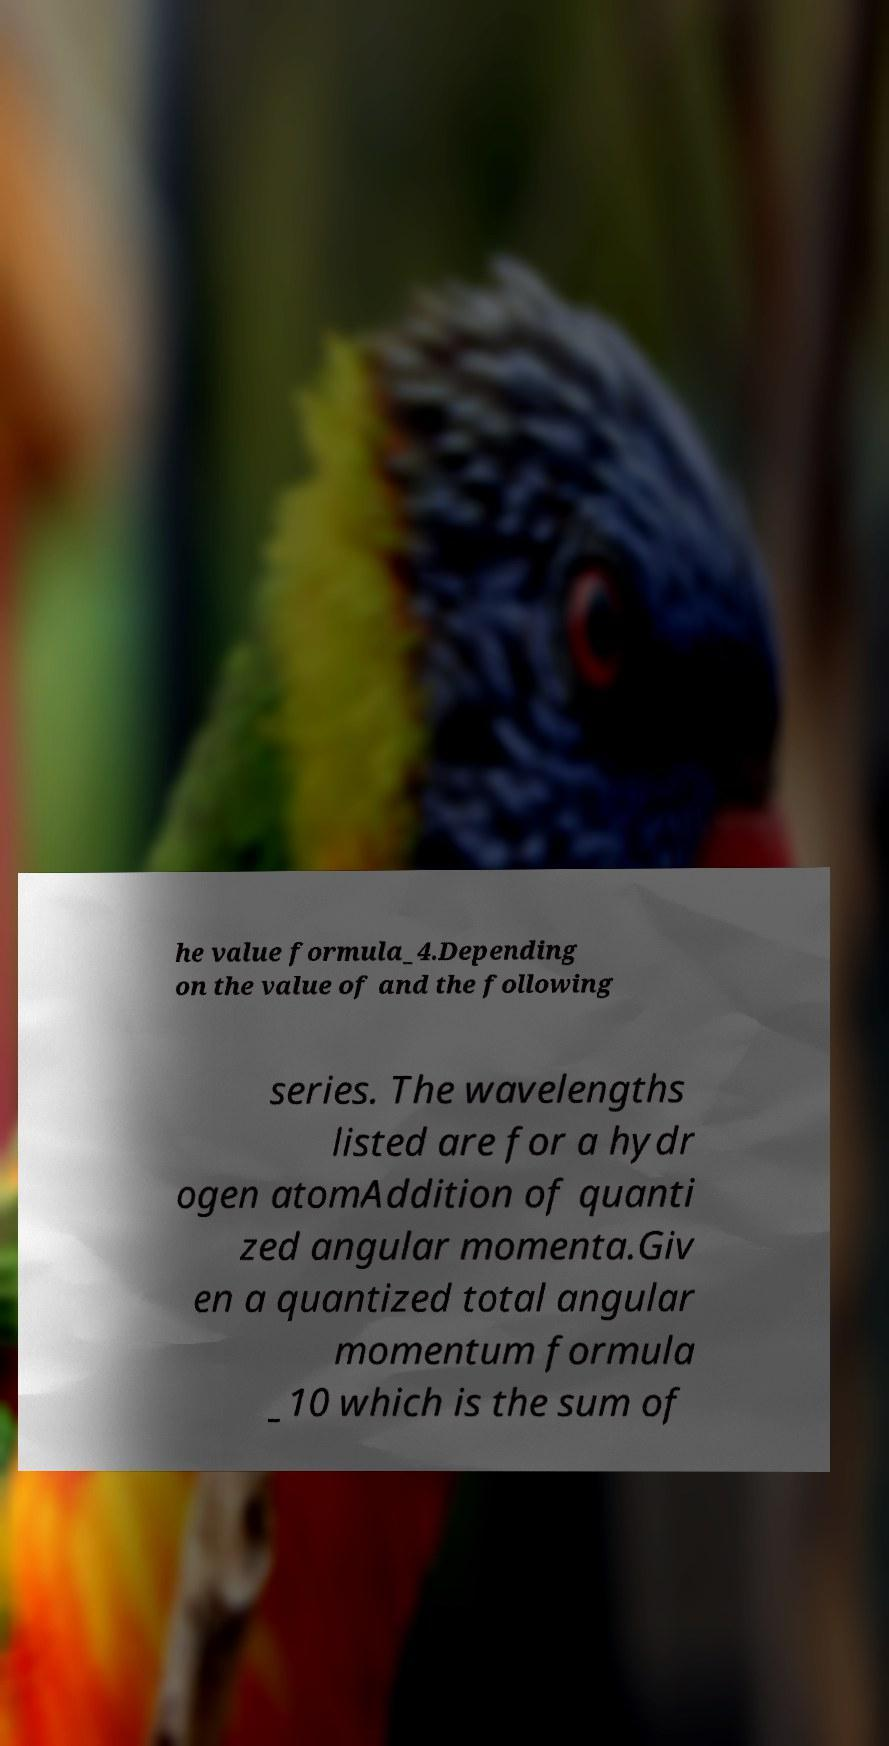Can you accurately transcribe the text from the provided image for me? he value formula_4.Depending on the value of and the following series. The wavelengths listed are for a hydr ogen atomAddition of quanti zed angular momenta.Giv en a quantized total angular momentum formula _10 which is the sum of 